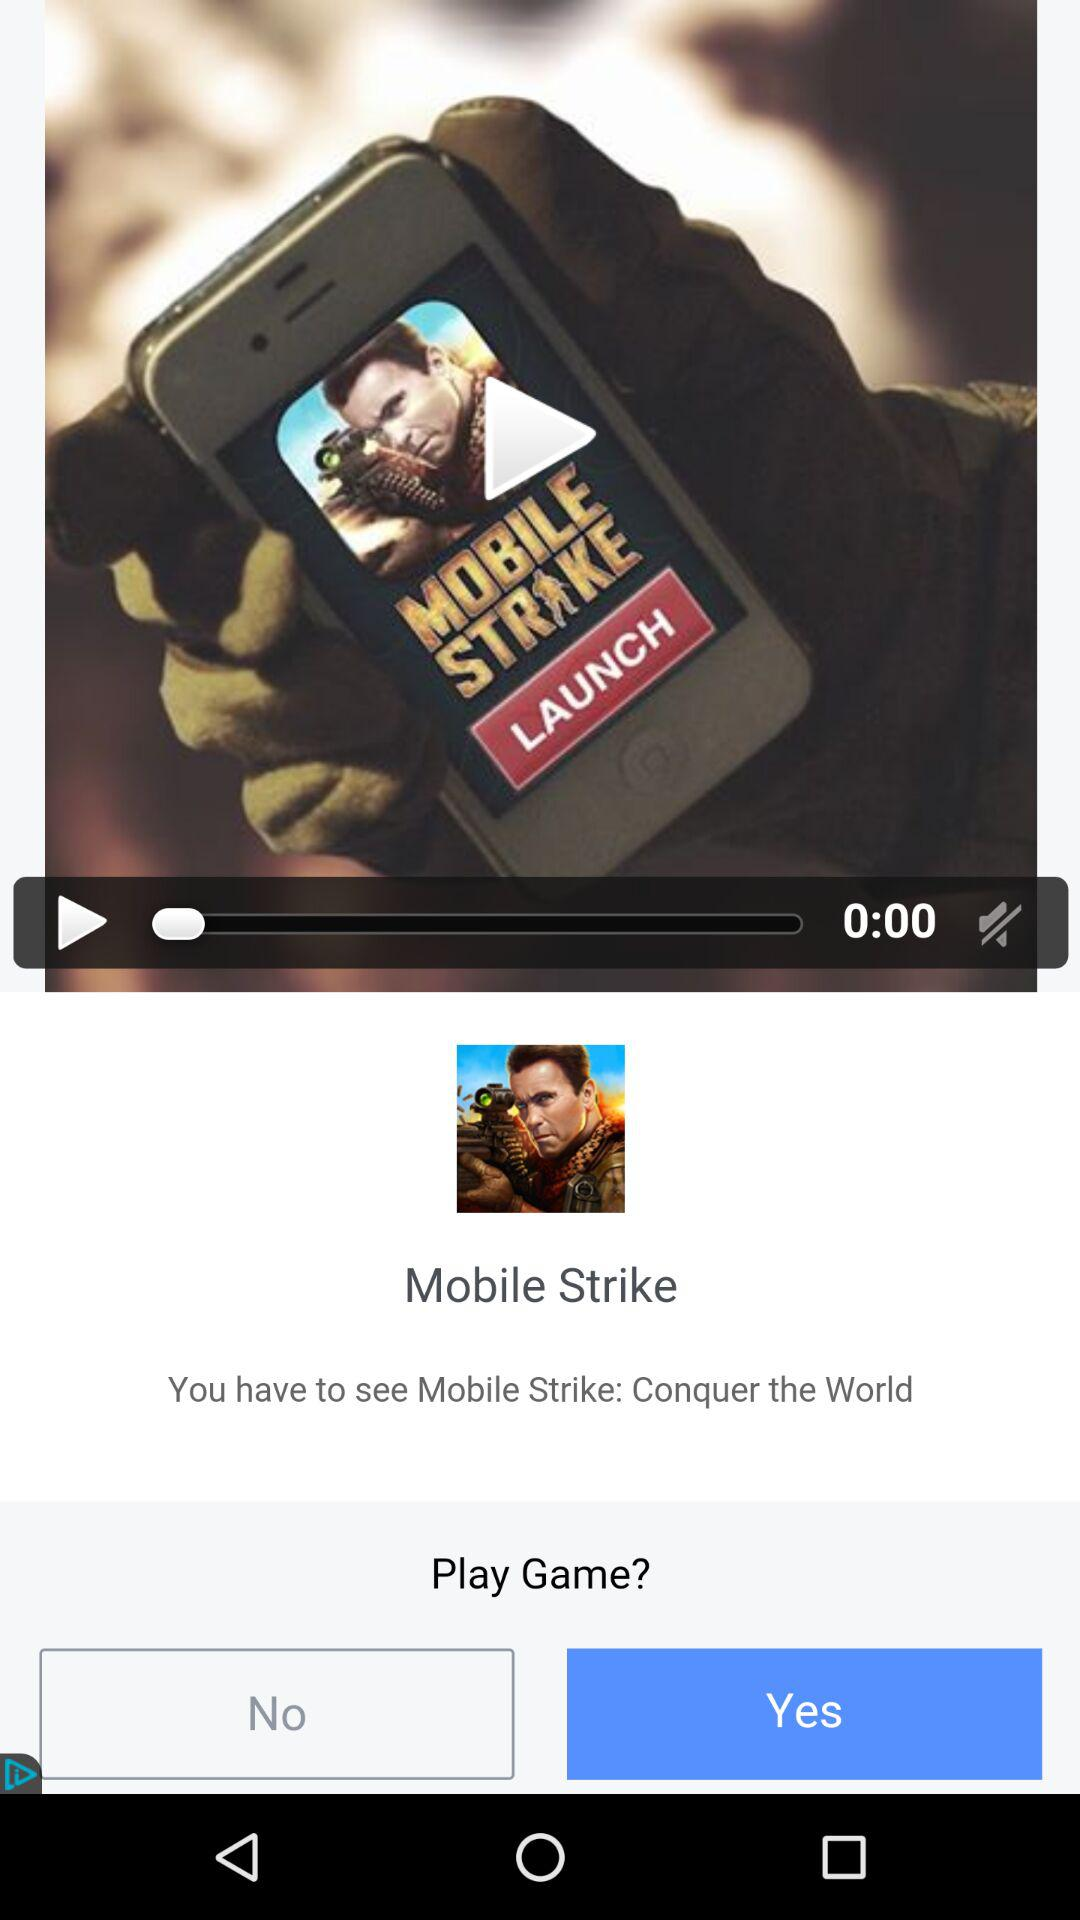How many seconds have elapsed since the game launched?
Answer the question using a single word or phrase. 0 